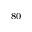Convert formula to latex. <formula><loc_0><loc_0><loc_500><loc_500>_ { 8 0 }</formula> 